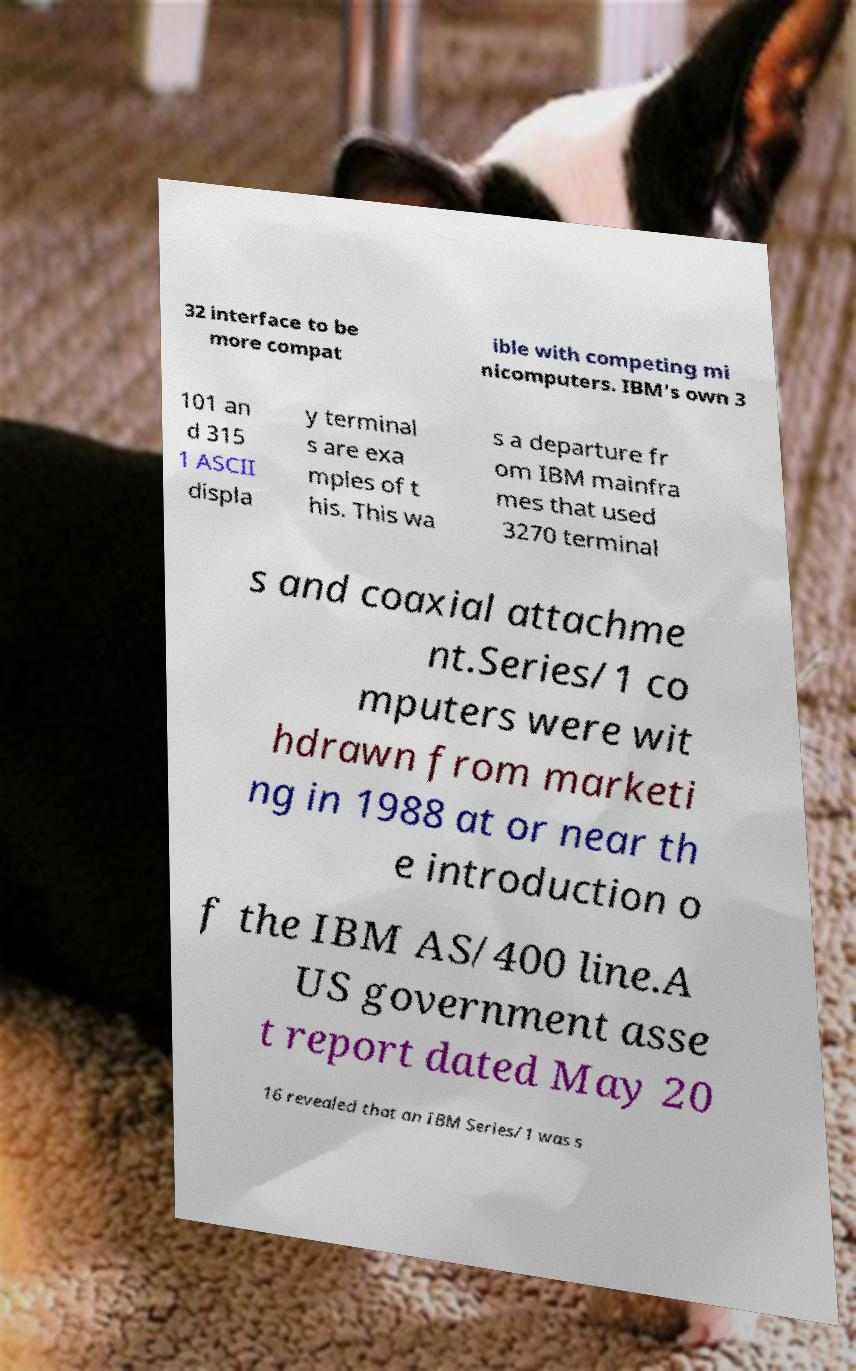There's text embedded in this image that I need extracted. Can you transcribe it verbatim? 32 interface to be more compat ible with competing mi nicomputers. IBM's own 3 101 an d 315 1 ASCII displa y terminal s are exa mples of t his. This wa s a departure fr om IBM mainfra mes that used 3270 terminal s and coaxial attachme nt.Series/1 co mputers were wit hdrawn from marketi ng in 1988 at or near th e introduction o f the IBM AS/400 line.A US government asse t report dated May 20 16 revealed that an IBM Series/1 was s 